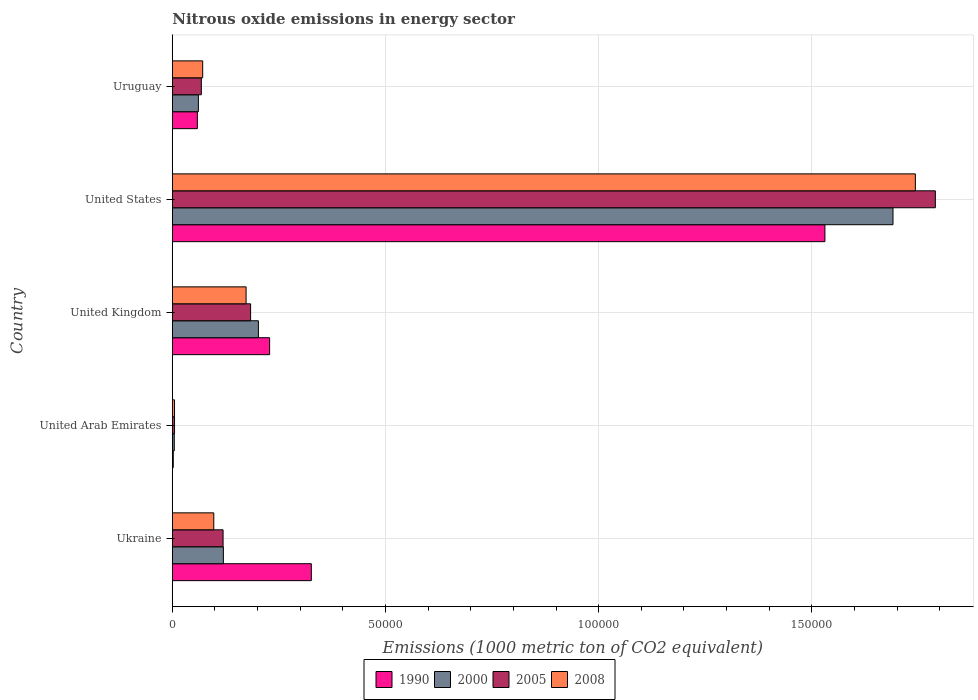How many bars are there on the 2nd tick from the top?
Your answer should be compact. 4. What is the label of the 5th group of bars from the top?
Provide a short and direct response. Ukraine. What is the amount of nitrous oxide emitted in 1990 in United States?
Provide a succinct answer. 1.53e+05. Across all countries, what is the maximum amount of nitrous oxide emitted in 2005?
Provide a short and direct response. 1.79e+05. Across all countries, what is the minimum amount of nitrous oxide emitted in 2000?
Keep it short and to the point. 453.6. In which country was the amount of nitrous oxide emitted in 2000 minimum?
Your response must be concise. United Arab Emirates. What is the total amount of nitrous oxide emitted in 1990 in the graph?
Your response must be concise. 2.15e+05. What is the difference between the amount of nitrous oxide emitted in 1990 in Ukraine and that in United Kingdom?
Ensure brevity in your answer.  9785.4. What is the difference between the amount of nitrous oxide emitted in 1990 in Ukraine and the amount of nitrous oxide emitted in 2000 in Uruguay?
Your response must be concise. 2.65e+04. What is the average amount of nitrous oxide emitted in 1990 per country?
Your answer should be very brief. 4.29e+04. What is the difference between the amount of nitrous oxide emitted in 2008 and amount of nitrous oxide emitted in 1990 in United States?
Ensure brevity in your answer.  2.12e+04. What is the ratio of the amount of nitrous oxide emitted in 1990 in Ukraine to that in United Kingdom?
Keep it short and to the point. 1.43. What is the difference between the highest and the second highest amount of nitrous oxide emitted in 2005?
Provide a succinct answer. 1.61e+05. What is the difference between the highest and the lowest amount of nitrous oxide emitted in 2000?
Provide a short and direct response. 1.69e+05. In how many countries, is the amount of nitrous oxide emitted in 2000 greater than the average amount of nitrous oxide emitted in 2000 taken over all countries?
Provide a succinct answer. 1. Is the sum of the amount of nitrous oxide emitted in 2000 in United Arab Emirates and Uruguay greater than the maximum amount of nitrous oxide emitted in 2008 across all countries?
Give a very brief answer. No. Is it the case that in every country, the sum of the amount of nitrous oxide emitted in 2000 and amount of nitrous oxide emitted in 2005 is greater than the sum of amount of nitrous oxide emitted in 2008 and amount of nitrous oxide emitted in 1990?
Provide a short and direct response. No. What does the 3rd bar from the top in United States represents?
Make the answer very short. 2000. Is it the case that in every country, the sum of the amount of nitrous oxide emitted in 1990 and amount of nitrous oxide emitted in 2000 is greater than the amount of nitrous oxide emitted in 2005?
Your response must be concise. Yes. Are all the bars in the graph horizontal?
Your answer should be very brief. Yes. Are the values on the major ticks of X-axis written in scientific E-notation?
Provide a short and direct response. No. Does the graph contain any zero values?
Ensure brevity in your answer.  No. Where does the legend appear in the graph?
Provide a short and direct response. Bottom center. How many legend labels are there?
Keep it short and to the point. 4. How are the legend labels stacked?
Give a very brief answer. Horizontal. What is the title of the graph?
Provide a succinct answer. Nitrous oxide emissions in energy sector. What is the label or title of the X-axis?
Give a very brief answer. Emissions (1000 metric ton of CO2 equivalent). What is the label or title of the Y-axis?
Make the answer very short. Country. What is the Emissions (1000 metric ton of CO2 equivalent) of 1990 in Ukraine?
Your response must be concise. 3.26e+04. What is the Emissions (1000 metric ton of CO2 equivalent) of 2000 in Ukraine?
Offer a terse response. 1.20e+04. What is the Emissions (1000 metric ton of CO2 equivalent) of 2005 in Ukraine?
Make the answer very short. 1.19e+04. What is the Emissions (1000 metric ton of CO2 equivalent) of 2008 in Ukraine?
Your answer should be compact. 9719.1. What is the Emissions (1000 metric ton of CO2 equivalent) of 1990 in United Arab Emirates?
Offer a terse response. 214.5. What is the Emissions (1000 metric ton of CO2 equivalent) of 2000 in United Arab Emirates?
Provide a succinct answer. 453.6. What is the Emissions (1000 metric ton of CO2 equivalent) of 2005 in United Arab Emirates?
Your answer should be very brief. 510.2. What is the Emissions (1000 metric ton of CO2 equivalent) in 2008 in United Arab Emirates?
Your response must be concise. 507.7. What is the Emissions (1000 metric ton of CO2 equivalent) of 1990 in United Kingdom?
Provide a succinct answer. 2.28e+04. What is the Emissions (1000 metric ton of CO2 equivalent) in 2000 in United Kingdom?
Give a very brief answer. 2.02e+04. What is the Emissions (1000 metric ton of CO2 equivalent) in 2005 in United Kingdom?
Your response must be concise. 1.84e+04. What is the Emissions (1000 metric ton of CO2 equivalent) of 2008 in United Kingdom?
Offer a very short reply. 1.73e+04. What is the Emissions (1000 metric ton of CO2 equivalent) in 1990 in United States?
Your answer should be compact. 1.53e+05. What is the Emissions (1000 metric ton of CO2 equivalent) of 2000 in United States?
Make the answer very short. 1.69e+05. What is the Emissions (1000 metric ton of CO2 equivalent) of 2005 in United States?
Give a very brief answer. 1.79e+05. What is the Emissions (1000 metric ton of CO2 equivalent) in 2008 in United States?
Your answer should be very brief. 1.74e+05. What is the Emissions (1000 metric ton of CO2 equivalent) of 1990 in Uruguay?
Provide a short and direct response. 5867.6. What is the Emissions (1000 metric ton of CO2 equivalent) in 2000 in Uruguay?
Offer a terse response. 6109. What is the Emissions (1000 metric ton of CO2 equivalent) in 2005 in Uruguay?
Your answer should be very brief. 6798.2. What is the Emissions (1000 metric ton of CO2 equivalent) of 2008 in Uruguay?
Provide a succinct answer. 7116. Across all countries, what is the maximum Emissions (1000 metric ton of CO2 equivalent) of 1990?
Offer a terse response. 1.53e+05. Across all countries, what is the maximum Emissions (1000 metric ton of CO2 equivalent) of 2000?
Offer a terse response. 1.69e+05. Across all countries, what is the maximum Emissions (1000 metric ton of CO2 equivalent) in 2005?
Offer a terse response. 1.79e+05. Across all countries, what is the maximum Emissions (1000 metric ton of CO2 equivalent) in 2008?
Provide a succinct answer. 1.74e+05. Across all countries, what is the minimum Emissions (1000 metric ton of CO2 equivalent) of 1990?
Make the answer very short. 214.5. Across all countries, what is the minimum Emissions (1000 metric ton of CO2 equivalent) in 2000?
Keep it short and to the point. 453.6. Across all countries, what is the minimum Emissions (1000 metric ton of CO2 equivalent) in 2005?
Give a very brief answer. 510.2. Across all countries, what is the minimum Emissions (1000 metric ton of CO2 equivalent) of 2008?
Provide a succinct answer. 507.7. What is the total Emissions (1000 metric ton of CO2 equivalent) in 1990 in the graph?
Give a very brief answer. 2.15e+05. What is the total Emissions (1000 metric ton of CO2 equivalent) in 2000 in the graph?
Make the answer very short. 2.08e+05. What is the total Emissions (1000 metric ton of CO2 equivalent) in 2005 in the graph?
Give a very brief answer. 2.17e+05. What is the total Emissions (1000 metric ton of CO2 equivalent) of 2008 in the graph?
Your answer should be compact. 2.09e+05. What is the difference between the Emissions (1000 metric ton of CO2 equivalent) in 1990 in Ukraine and that in United Arab Emirates?
Your answer should be compact. 3.24e+04. What is the difference between the Emissions (1000 metric ton of CO2 equivalent) in 2000 in Ukraine and that in United Arab Emirates?
Your answer should be very brief. 1.15e+04. What is the difference between the Emissions (1000 metric ton of CO2 equivalent) of 2005 in Ukraine and that in United Arab Emirates?
Your answer should be very brief. 1.14e+04. What is the difference between the Emissions (1000 metric ton of CO2 equivalent) in 2008 in Ukraine and that in United Arab Emirates?
Your answer should be compact. 9211.4. What is the difference between the Emissions (1000 metric ton of CO2 equivalent) in 1990 in Ukraine and that in United Kingdom?
Offer a very short reply. 9785.4. What is the difference between the Emissions (1000 metric ton of CO2 equivalent) in 2000 in Ukraine and that in United Kingdom?
Offer a terse response. -8217.1. What is the difference between the Emissions (1000 metric ton of CO2 equivalent) in 2005 in Ukraine and that in United Kingdom?
Give a very brief answer. -6455.5. What is the difference between the Emissions (1000 metric ton of CO2 equivalent) of 2008 in Ukraine and that in United Kingdom?
Keep it short and to the point. -7578.1. What is the difference between the Emissions (1000 metric ton of CO2 equivalent) of 1990 in Ukraine and that in United States?
Give a very brief answer. -1.20e+05. What is the difference between the Emissions (1000 metric ton of CO2 equivalent) of 2000 in Ukraine and that in United States?
Your answer should be compact. -1.57e+05. What is the difference between the Emissions (1000 metric ton of CO2 equivalent) in 2005 in Ukraine and that in United States?
Your response must be concise. -1.67e+05. What is the difference between the Emissions (1000 metric ton of CO2 equivalent) of 2008 in Ukraine and that in United States?
Ensure brevity in your answer.  -1.65e+05. What is the difference between the Emissions (1000 metric ton of CO2 equivalent) of 1990 in Ukraine and that in Uruguay?
Make the answer very short. 2.67e+04. What is the difference between the Emissions (1000 metric ton of CO2 equivalent) of 2000 in Ukraine and that in Uruguay?
Keep it short and to the point. 5858.9. What is the difference between the Emissions (1000 metric ton of CO2 equivalent) in 2005 in Ukraine and that in Uruguay?
Offer a terse response. 5099.3. What is the difference between the Emissions (1000 metric ton of CO2 equivalent) of 2008 in Ukraine and that in Uruguay?
Make the answer very short. 2603.1. What is the difference between the Emissions (1000 metric ton of CO2 equivalent) in 1990 in United Arab Emirates and that in United Kingdom?
Offer a terse response. -2.26e+04. What is the difference between the Emissions (1000 metric ton of CO2 equivalent) in 2000 in United Arab Emirates and that in United Kingdom?
Offer a very short reply. -1.97e+04. What is the difference between the Emissions (1000 metric ton of CO2 equivalent) of 2005 in United Arab Emirates and that in United Kingdom?
Make the answer very short. -1.78e+04. What is the difference between the Emissions (1000 metric ton of CO2 equivalent) in 2008 in United Arab Emirates and that in United Kingdom?
Your answer should be compact. -1.68e+04. What is the difference between the Emissions (1000 metric ton of CO2 equivalent) of 1990 in United Arab Emirates and that in United States?
Your answer should be compact. -1.53e+05. What is the difference between the Emissions (1000 metric ton of CO2 equivalent) in 2000 in United Arab Emirates and that in United States?
Offer a very short reply. -1.69e+05. What is the difference between the Emissions (1000 metric ton of CO2 equivalent) of 2005 in United Arab Emirates and that in United States?
Offer a terse response. -1.78e+05. What is the difference between the Emissions (1000 metric ton of CO2 equivalent) in 2008 in United Arab Emirates and that in United States?
Your answer should be very brief. -1.74e+05. What is the difference between the Emissions (1000 metric ton of CO2 equivalent) in 1990 in United Arab Emirates and that in Uruguay?
Your response must be concise. -5653.1. What is the difference between the Emissions (1000 metric ton of CO2 equivalent) in 2000 in United Arab Emirates and that in Uruguay?
Ensure brevity in your answer.  -5655.4. What is the difference between the Emissions (1000 metric ton of CO2 equivalent) in 2005 in United Arab Emirates and that in Uruguay?
Ensure brevity in your answer.  -6288. What is the difference between the Emissions (1000 metric ton of CO2 equivalent) in 2008 in United Arab Emirates and that in Uruguay?
Give a very brief answer. -6608.3. What is the difference between the Emissions (1000 metric ton of CO2 equivalent) of 1990 in United Kingdom and that in United States?
Provide a short and direct response. -1.30e+05. What is the difference between the Emissions (1000 metric ton of CO2 equivalent) of 2000 in United Kingdom and that in United States?
Keep it short and to the point. -1.49e+05. What is the difference between the Emissions (1000 metric ton of CO2 equivalent) of 2005 in United Kingdom and that in United States?
Offer a very short reply. -1.61e+05. What is the difference between the Emissions (1000 metric ton of CO2 equivalent) in 2008 in United Kingdom and that in United States?
Your response must be concise. -1.57e+05. What is the difference between the Emissions (1000 metric ton of CO2 equivalent) of 1990 in United Kingdom and that in Uruguay?
Give a very brief answer. 1.69e+04. What is the difference between the Emissions (1000 metric ton of CO2 equivalent) in 2000 in United Kingdom and that in Uruguay?
Give a very brief answer. 1.41e+04. What is the difference between the Emissions (1000 metric ton of CO2 equivalent) in 2005 in United Kingdom and that in Uruguay?
Offer a very short reply. 1.16e+04. What is the difference between the Emissions (1000 metric ton of CO2 equivalent) of 2008 in United Kingdom and that in Uruguay?
Provide a short and direct response. 1.02e+04. What is the difference between the Emissions (1000 metric ton of CO2 equivalent) in 1990 in United States and that in Uruguay?
Give a very brief answer. 1.47e+05. What is the difference between the Emissions (1000 metric ton of CO2 equivalent) in 2000 in United States and that in Uruguay?
Provide a succinct answer. 1.63e+05. What is the difference between the Emissions (1000 metric ton of CO2 equivalent) in 2005 in United States and that in Uruguay?
Give a very brief answer. 1.72e+05. What is the difference between the Emissions (1000 metric ton of CO2 equivalent) of 2008 in United States and that in Uruguay?
Offer a very short reply. 1.67e+05. What is the difference between the Emissions (1000 metric ton of CO2 equivalent) in 1990 in Ukraine and the Emissions (1000 metric ton of CO2 equivalent) in 2000 in United Arab Emirates?
Your answer should be very brief. 3.21e+04. What is the difference between the Emissions (1000 metric ton of CO2 equivalent) in 1990 in Ukraine and the Emissions (1000 metric ton of CO2 equivalent) in 2005 in United Arab Emirates?
Your response must be concise. 3.21e+04. What is the difference between the Emissions (1000 metric ton of CO2 equivalent) in 1990 in Ukraine and the Emissions (1000 metric ton of CO2 equivalent) in 2008 in United Arab Emirates?
Provide a succinct answer. 3.21e+04. What is the difference between the Emissions (1000 metric ton of CO2 equivalent) of 2000 in Ukraine and the Emissions (1000 metric ton of CO2 equivalent) of 2005 in United Arab Emirates?
Provide a succinct answer. 1.15e+04. What is the difference between the Emissions (1000 metric ton of CO2 equivalent) in 2000 in Ukraine and the Emissions (1000 metric ton of CO2 equivalent) in 2008 in United Arab Emirates?
Your response must be concise. 1.15e+04. What is the difference between the Emissions (1000 metric ton of CO2 equivalent) of 2005 in Ukraine and the Emissions (1000 metric ton of CO2 equivalent) of 2008 in United Arab Emirates?
Offer a terse response. 1.14e+04. What is the difference between the Emissions (1000 metric ton of CO2 equivalent) in 1990 in Ukraine and the Emissions (1000 metric ton of CO2 equivalent) in 2000 in United Kingdom?
Give a very brief answer. 1.24e+04. What is the difference between the Emissions (1000 metric ton of CO2 equivalent) of 1990 in Ukraine and the Emissions (1000 metric ton of CO2 equivalent) of 2005 in United Kingdom?
Keep it short and to the point. 1.42e+04. What is the difference between the Emissions (1000 metric ton of CO2 equivalent) in 1990 in Ukraine and the Emissions (1000 metric ton of CO2 equivalent) in 2008 in United Kingdom?
Provide a succinct answer. 1.53e+04. What is the difference between the Emissions (1000 metric ton of CO2 equivalent) in 2000 in Ukraine and the Emissions (1000 metric ton of CO2 equivalent) in 2005 in United Kingdom?
Make the answer very short. -6385.1. What is the difference between the Emissions (1000 metric ton of CO2 equivalent) of 2000 in Ukraine and the Emissions (1000 metric ton of CO2 equivalent) of 2008 in United Kingdom?
Make the answer very short. -5329.3. What is the difference between the Emissions (1000 metric ton of CO2 equivalent) in 2005 in Ukraine and the Emissions (1000 metric ton of CO2 equivalent) in 2008 in United Kingdom?
Provide a short and direct response. -5399.7. What is the difference between the Emissions (1000 metric ton of CO2 equivalent) of 1990 in Ukraine and the Emissions (1000 metric ton of CO2 equivalent) of 2000 in United States?
Your answer should be compact. -1.36e+05. What is the difference between the Emissions (1000 metric ton of CO2 equivalent) in 1990 in Ukraine and the Emissions (1000 metric ton of CO2 equivalent) in 2005 in United States?
Offer a very short reply. -1.46e+05. What is the difference between the Emissions (1000 metric ton of CO2 equivalent) in 1990 in Ukraine and the Emissions (1000 metric ton of CO2 equivalent) in 2008 in United States?
Keep it short and to the point. -1.42e+05. What is the difference between the Emissions (1000 metric ton of CO2 equivalent) in 2000 in Ukraine and the Emissions (1000 metric ton of CO2 equivalent) in 2005 in United States?
Your answer should be very brief. -1.67e+05. What is the difference between the Emissions (1000 metric ton of CO2 equivalent) in 2000 in Ukraine and the Emissions (1000 metric ton of CO2 equivalent) in 2008 in United States?
Your response must be concise. -1.62e+05. What is the difference between the Emissions (1000 metric ton of CO2 equivalent) of 2005 in Ukraine and the Emissions (1000 metric ton of CO2 equivalent) of 2008 in United States?
Your answer should be compact. -1.62e+05. What is the difference between the Emissions (1000 metric ton of CO2 equivalent) of 1990 in Ukraine and the Emissions (1000 metric ton of CO2 equivalent) of 2000 in Uruguay?
Ensure brevity in your answer.  2.65e+04. What is the difference between the Emissions (1000 metric ton of CO2 equivalent) in 1990 in Ukraine and the Emissions (1000 metric ton of CO2 equivalent) in 2005 in Uruguay?
Keep it short and to the point. 2.58e+04. What is the difference between the Emissions (1000 metric ton of CO2 equivalent) in 1990 in Ukraine and the Emissions (1000 metric ton of CO2 equivalent) in 2008 in Uruguay?
Offer a terse response. 2.55e+04. What is the difference between the Emissions (1000 metric ton of CO2 equivalent) in 2000 in Ukraine and the Emissions (1000 metric ton of CO2 equivalent) in 2005 in Uruguay?
Make the answer very short. 5169.7. What is the difference between the Emissions (1000 metric ton of CO2 equivalent) in 2000 in Ukraine and the Emissions (1000 metric ton of CO2 equivalent) in 2008 in Uruguay?
Your response must be concise. 4851.9. What is the difference between the Emissions (1000 metric ton of CO2 equivalent) of 2005 in Ukraine and the Emissions (1000 metric ton of CO2 equivalent) of 2008 in Uruguay?
Provide a short and direct response. 4781.5. What is the difference between the Emissions (1000 metric ton of CO2 equivalent) in 1990 in United Arab Emirates and the Emissions (1000 metric ton of CO2 equivalent) in 2000 in United Kingdom?
Provide a succinct answer. -2.00e+04. What is the difference between the Emissions (1000 metric ton of CO2 equivalent) in 1990 in United Arab Emirates and the Emissions (1000 metric ton of CO2 equivalent) in 2005 in United Kingdom?
Make the answer very short. -1.81e+04. What is the difference between the Emissions (1000 metric ton of CO2 equivalent) of 1990 in United Arab Emirates and the Emissions (1000 metric ton of CO2 equivalent) of 2008 in United Kingdom?
Provide a succinct answer. -1.71e+04. What is the difference between the Emissions (1000 metric ton of CO2 equivalent) of 2000 in United Arab Emirates and the Emissions (1000 metric ton of CO2 equivalent) of 2005 in United Kingdom?
Ensure brevity in your answer.  -1.79e+04. What is the difference between the Emissions (1000 metric ton of CO2 equivalent) of 2000 in United Arab Emirates and the Emissions (1000 metric ton of CO2 equivalent) of 2008 in United Kingdom?
Offer a very short reply. -1.68e+04. What is the difference between the Emissions (1000 metric ton of CO2 equivalent) in 2005 in United Arab Emirates and the Emissions (1000 metric ton of CO2 equivalent) in 2008 in United Kingdom?
Offer a terse response. -1.68e+04. What is the difference between the Emissions (1000 metric ton of CO2 equivalent) in 1990 in United Arab Emirates and the Emissions (1000 metric ton of CO2 equivalent) in 2000 in United States?
Provide a succinct answer. -1.69e+05. What is the difference between the Emissions (1000 metric ton of CO2 equivalent) of 1990 in United Arab Emirates and the Emissions (1000 metric ton of CO2 equivalent) of 2005 in United States?
Ensure brevity in your answer.  -1.79e+05. What is the difference between the Emissions (1000 metric ton of CO2 equivalent) in 1990 in United Arab Emirates and the Emissions (1000 metric ton of CO2 equivalent) in 2008 in United States?
Offer a terse response. -1.74e+05. What is the difference between the Emissions (1000 metric ton of CO2 equivalent) in 2000 in United Arab Emirates and the Emissions (1000 metric ton of CO2 equivalent) in 2005 in United States?
Keep it short and to the point. -1.79e+05. What is the difference between the Emissions (1000 metric ton of CO2 equivalent) of 2000 in United Arab Emirates and the Emissions (1000 metric ton of CO2 equivalent) of 2008 in United States?
Your answer should be very brief. -1.74e+05. What is the difference between the Emissions (1000 metric ton of CO2 equivalent) of 2005 in United Arab Emirates and the Emissions (1000 metric ton of CO2 equivalent) of 2008 in United States?
Provide a succinct answer. -1.74e+05. What is the difference between the Emissions (1000 metric ton of CO2 equivalent) in 1990 in United Arab Emirates and the Emissions (1000 metric ton of CO2 equivalent) in 2000 in Uruguay?
Provide a short and direct response. -5894.5. What is the difference between the Emissions (1000 metric ton of CO2 equivalent) of 1990 in United Arab Emirates and the Emissions (1000 metric ton of CO2 equivalent) of 2005 in Uruguay?
Offer a terse response. -6583.7. What is the difference between the Emissions (1000 metric ton of CO2 equivalent) of 1990 in United Arab Emirates and the Emissions (1000 metric ton of CO2 equivalent) of 2008 in Uruguay?
Make the answer very short. -6901.5. What is the difference between the Emissions (1000 metric ton of CO2 equivalent) in 2000 in United Arab Emirates and the Emissions (1000 metric ton of CO2 equivalent) in 2005 in Uruguay?
Give a very brief answer. -6344.6. What is the difference between the Emissions (1000 metric ton of CO2 equivalent) in 2000 in United Arab Emirates and the Emissions (1000 metric ton of CO2 equivalent) in 2008 in Uruguay?
Offer a very short reply. -6662.4. What is the difference between the Emissions (1000 metric ton of CO2 equivalent) in 2005 in United Arab Emirates and the Emissions (1000 metric ton of CO2 equivalent) in 2008 in Uruguay?
Your response must be concise. -6605.8. What is the difference between the Emissions (1000 metric ton of CO2 equivalent) of 1990 in United Kingdom and the Emissions (1000 metric ton of CO2 equivalent) of 2000 in United States?
Your answer should be compact. -1.46e+05. What is the difference between the Emissions (1000 metric ton of CO2 equivalent) in 1990 in United Kingdom and the Emissions (1000 metric ton of CO2 equivalent) in 2005 in United States?
Your answer should be very brief. -1.56e+05. What is the difference between the Emissions (1000 metric ton of CO2 equivalent) of 1990 in United Kingdom and the Emissions (1000 metric ton of CO2 equivalent) of 2008 in United States?
Provide a succinct answer. -1.51e+05. What is the difference between the Emissions (1000 metric ton of CO2 equivalent) of 2000 in United Kingdom and the Emissions (1000 metric ton of CO2 equivalent) of 2005 in United States?
Your response must be concise. -1.59e+05. What is the difference between the Emissions (1000 metric ton of CO2 equivalent) in 2000 in United Kingdom and the Emissions (1000 metric ton of CO2 equivalent) in 2008 in United States?
Your answer should be compact. -1.54e+05. What is the difference between the Emissions (1000 metric ton of CO2 equivalent) in 2005 in United Kingdom and the Emissions (1000 metric ton of CO2 equivalent) in 2008 in United States?
Your answer should be compact. -1.56e+05. What is the difference between the Emissions (1000 metric ton of CO2 equivalent) of 1990 in United Kingdom and the Emissions (1000 metric ton of CO2 equivalent) of 2000 in Uruguay?
Provide a short and direct response. 1.67e+04. What is the difference between the Emissions (1000 metric ton of CO2 equivalent) of 1990 in United Kingdom and the Emissions (1000 metric ton of CO2 equivalent) of 2005 in Uruguay?
Make the answer very short. 1.60e+04. What is the difference between the Emissions (1000 metric ton of CO2 equivalent) of 1990 in United Kingdom and the Emissions (1000 metric ton of CO2 equivalent) of 2008 in Uruguay?
Your answer should be very brief. 1.57e+04. What is the difference between the Emissions (1000 metric ton of CO2 equivalent) of 2000 in United Kingdom and the Emissions (1000 metric ton of CO2 equivalent) of 2005 in Uruguay?
Make the answer very short. 1.34e+04. What is the difference between the Emissions (1000 metric ton of CO2 equivalent) in 2000 in United Kingdom and the Emissions (1000 metric ton of CO2 equivalent) in 2008 in Uruguay?
Provide a short and direct response. 1.31e+04. What is the difference between the Emissions (1000 metric ton of CO2 equivalent) in 2005 in United Kingdom and the Emissions (1000 metric ton of CO2 equivalent) in 2008 in Uruguay?
Provide a succinct answer. 1.12e+04. What is the difference between the Emissions (1000 metric ton of CO2 equivalent) in 1990 in United States and the Emissions (1000 metric ton of CO2 equivalent) in 2000 in Uruguay?
Give a very brief answer. 1.47e+05. What is the difference between the Emissions (1000 metric ton of CO2 equivalent) in 1990 in United States and the Emissions (1000 metric ton of CO2 equivalent) in 2005 in Uruguay?
Ensure brevity in your answer.  1.46e+05. What is the difference between the Emissions (1000 metric ton of CO2 equivalent) of 1990 in United States and the Emissions (1000 metric ton of CO2 equivalent) of 2008 in Uruguay?
Offer a very short reply. 1.46e+05. What is the difference between the Emissions (1000 metric ton of CO2 equivalent) of 2000 in United States and the Emissions (1000 metric ton of CO2 equivalent) of 2005 in Uruguay?
Make the answer very short. 1.62e+05. What is the difference between the Emissions (1000 metric ton of CO2 equivalent) in 2000 in United States and the Emissions (1000 metric ton of CO2 equivalent) in 2008 in Uruguay?
Ensure brevity in your answer.  1.62e+05. What is the difference between the Emissions (1000 metric ton of CO2 equivalent) in 2005 in United States and the Emissions (1000 metric ton of CO2 equivalent) in 2008 in Uruguay?
Provide a succinct answer. 1.72e+05. What is the average Emissions (1000 metric ton of CO2 equivalent) in 1990 per country?
Make the answer very short. 4.29e+04. What is the average Emissions (1000 metric ton of CO2 equivalent) of 2000 per country?
Offer a very short reply. 4.16e+04. What is the average Emissions (1000 metric ton of CO2 equivalent) in 2005 per country?
Your answer should be compact. 4.33e+04. What is the average Emissions (1000 metric ton of CO2 equivalent) in 2008 per country?
Ensure brevity in your answer.  4.18e+04. What is the difference between the Emissions (1000 metric ton of CO2 equivalent) in 1990 and Emissions (1000 metric ton of CO2 equivalent) in 2000 in Ukraine?
Ensure brevity in your answer.  2.06e+04. What is the difference between the Emissions (1000 metric ton of CO2 equivalent) of 1990 and Emissions (1000 metric ton of CO2 equivalent) of 2005 in Ukraine?
Your response must be concise. 2.07e+04. What is the difference between the Emissions (1000 metric ton of CO2 equivalent) in 1990 and Emissions (1000 metric ton of CO2 equivalent) in 2008 in Ukraine?
Provide a short and direct response. 2.29e+04. What is the difference between the Emissions (1000 metric ton of CO2 equivalent) in 2000 and Emissions (1000 metric ton of CO2 equivalent) in 2005 in Ukraine?
Your response must be concise. 70.4. What is the difference between the Emissions (1000 metric ton of CO2 equivalent) of 2000 and Emissions (1000 metric ton of CO2 equivalent) of 2008 in Ukraine?
Your answer should be compact. 2248.8. What is the difference between the Emissions (1000 metric ton of CO2 equivalent) of 2005 and Emissions (1000 metric ton of CO2 equivalent) of 2008 in Ukraine?
Offer a terse response. 2178.4. What is the difference between the Emissions (1000 metric ton of CO2 equivalent) in 1990 and Emissions (1000 metric ton of CO2 equivalent) in 2000 in United Arab Emirates?
Offer a very short reply. -239.1. What is the difference between the Emissions (1000 metric ton of CO2 equivalent) in 1990 and Emissions (1000 metric ton of CO2 equivalent) in 2005 in United Arab Emirates?
Your answer should be compact. -295.7. What is the difference between the Emissions (1000 metric ton of CO2 equivalent) of 1990 and Emissions (1000 metric ton of CO2 equivalent) of 2008 in United Arab Emirates?
Your response must be concise. -293.2. What is the difference between the Emissions (1000 metric ton of CO2 equivalent) of 2000 and Emissions (1000 metric ton of CO2 equivalent) of 2005 in United Arab Emirates?
Make the answer very short. -56.6. What is the difference between the Emissions (1000 metric ton of CO2 equivalent) of 2000 and Emissions (1000 metric ton of CO2 equivalent) of 2008 in United Arab Emirates?
Your answer should be very brief. -54.1. What is the difference between the Emissions (1000 metric ton of CO2 equivalent) of 2005 and Emissions (1000 metric ton of CO2 equivalent) of 2008 in United Arab Emirates?
Give a very brief answer. 2.5. What is the difference between the Emissions (1000 metric ton of CO2 equivalent) of 1990 and Emissions (1000 metric ton of CO2 equivalent) of 2000 in United Kingdom?
Your answer should be compact. 2628.9. What is the difference between the Emissions (1000 metric ton of CO2 equivalent) in 1990 and Emissions (1000 metric ton of CO2 equivalent) in 2005 in United Kingdom?
Offer a terse response. 4460.9. What is the difference between the Emissions (1000 metric ton of CO2 equivalent) in 1990 and Emissions (1000 metric ton of CO2 equivalent) in 2008 in United Kingdom?
Your answer should be compact. 5516.7. What is the difference between the Emissions (1000 metric ton of CO2 equivalent) of 2000 and Emissions (1000 metric ton of CO2 equivalent) of 2005 in United Kingdom?
Your response must be concise. 1832. What is the difference between the Emissions (1000 metric ton of CO2 equivalent) of 2000 and Emissions (1000 metric ton of CO2 equivalent) of 2008 in United Kingdom?
Your response must be concise. 2887.8. What is the difference between the Emissions (1000 metric ton of CO2 equivalent) of 2005 and Emissions (1000 metric ton of CO2 equivalent) of 2008 in United Kingdom?
Your response must be concise. 1055.8. What is the difference between the Emissions (1000 metric ton of CO2 equivalent) in 1990 and Emissions (1000 metric ton of CO2 equivalent) in 2000 in United States?
Offer a terse response. -1.60e+04. What is the difference between the Emissions (1000 metric ton of CO2 equivalent) of 1990 and Emissions (1000 metric ton of CO2 equivalent) of 2005 in United States?
Your answer should be compact. -2.59e+04. What is the difference between the Emissions (1000 metric ton of CO2 equivalent) in 1990 and Emissions (1000 metric ton of CO2 equivalent) in 2008 in United States?
Provide a succinct answer. -2.12e+04. What is the difference between the Emissions (1000 metric ton of CO2 equivalent) of 2000 and Emissions (1000 metric ton of CO2 equivalent) of 2005 in United States?
Your answer should be very brief. -9931.2. What is the difference between the Emissions (1000 metric ton of CO2 equivalent) of 2000 and Emissions (1000 metric ton of CO2 equivalent) of 2008 in United States?
Keep it short and to the point. -5242.4. What is the difference between the Emissions (1000 metric ton of CO2 equivalent) in 2005 and Emissions (1000 metric ton of CO2 equivalent) in 2008 in United States?
Give a very brief answer. 4688.8. What is the difference between the Emissions (1000 metric ton of CO2 equivalent) in 1990 and Emissions (1000 metric ton of CO2 equivalent) in 2000 in Uruguay?
Offer a terse response. -241.4. What is the difference between the Emissions (1000 metric ton of CO2 equivalent) of 1990 and Emissions (1000 metric ton of CO2 equivalent) of 2005 in Uruguay?
Offer a very short reply. -930.6. What is the difference between the Emissions (1000 metric ton of CO2 equivalent) in 1990 and Emissions (1000 metric ton of CO2 equivalent) in 2008 in Uruguay?
Provide a short and direct response. -1248.4. What is the difference between the Emissions (1000 metric ton of CO2 equivalent) of 2000 and Emissions (1000 metric ton of CO2 equivalent) of 2005 in Uruguay?
Ensure brevity in your answer.  -689.2. What is the difference between the Emissions (1000 metric ton of CO2 equivalent) in 2000 and Emissions (1000 metric ton of CO2 equivalent) in 2008 in Uruguay?
Your response must be concise. -1007. What is the difference between the Emissions (1000 metric ton of CO2 equivalent) of 2005 and Emissions (1000 metric ton of CO2 equivalent) of 2008 in Uruguay?
Your response must be concise. -317.8. What is the ratio of the Emissions (1000 metric ton of CO2 equivalent) in 1990 in Ukraine to that in United Arab Emirates?
Offer a terse response. 151.98. What is the ratio of the Emissions (1000 metric ton of CO2 equivalent) of 2000 in Ukraine to that in United Arab Emirates?
Ensure brevity in your answer.  26.38. What is the ratio of the Emissions (1000 metric ton of CO2 equivalent) in 2005 in Ukraine to that in United Arab Emirates?
Keep it short and to the point. 23.32. What is the ratio of the Emissions (1000 metric ton of CO2 equivalent) in 2008 in Ukraine to that in United Arab Emirates?
Give a very brief answer. 19.14. What is the ratio of the Emissions (1000 metric ton of CO2 equivalent) in 1990 in Ukraine to that in United Kingdom?
Ensure brevity in your answer.  1.43. What is the ratio of the Emissions (1000 metric ton of CO2 equivalent) of 2000 in Ukraine to that in United Kingdom?
Your response must be concise. 0.59. What is the ratio of the Emissions (1000 metric ton of CO2 equivalent) of 2005 in Ukraine to that in United Kingdom?
Provide a short and direct response. 0.65. What is the ratio of the Emissions (1000 metric ton of CO2 equivalent) in 2008 in Ukraine to that in United Kingdom?
Make the answer very short. 0.56. What is the ratio of the Emissions (1000 metric ton of CO2 equivalent) in 1990 in Ukraine to that in United States?
Offer a very short reply. 0.21. What is the ratio of the Emissions (1000 metric ton of CO2 equivalent) of 2000 in Ukraine to that in United States?
Give a very brief answer. 0.07. What is the ratio of the Emissions (1000 metric ton of CO2 equivalent) in 2005 in Ukraine to that in United States?
Ensure brevity in your answer.  0.07. What is the ratio of the Emissions (1000 metric ton of CO2 equivalent) of 2008 in Ukraine to that in United States?
Your answer should be compact. 0.06. What is the ratio of the Emissions (1000 metric ton of CO2 equivalent) in 1990 in Ukraine to that in Uruguay?
Offer a terse response. 5.56. What is the ratio of the Emissions (1000 metric ton of CO2 equivalent) in 2000 in Ukraine to that in Uruguay?
Provide a short and direct response. 1.96. What is the ratio of the Emissions (1000 metric ton of CO2 equivalent) in 2005 in Ukraine to that in Uruguay?
Offer a terse response. 1.75. What is the ratio of the Emissions (1000 metric ton of CO2 equivalent) of 2008 in Ukraine to that in Uruguay?
Your answer should be very brief. 1.37. What is the ratio of the Emissions (1000 metric ton of CO2 equivalent) of 1990 in United Arab Emirates to that in United Kingdom?
Ensure brevity in your answer.  0.01. What is the ratio of the Emissions (1000 metric ton of CO2 equivalent) in 2000 in United Arab Emirates to that in United Kingdom?
Keep it short and to the point. 0.02. What is the ratio of the Emissions (1000 metric ton of CO2 equivalent) in 2005 in United Arab Emirates to that in United Kingdom?
Offer a terse response. 0.03. What is the ratio of the Emissions (1000 metric ton of CO2 equivalent) of 2008 in United Arab Emirates to that in United Kingdom?
Ensure brevity in your answer.  0.03. What is the ratio of the Emissions (1000 metric ton of CO2 equivalent) of 1990 in United Arab Emirates to that in United States?
Ensure brevity in your answer.  0. What is the ratio of the Emissions (1000 metric ton of CO2 equivalent) in 2000 in United Arab Emirates to that in United States?
Provide a short and direct response. 0. What is the ratio of the Emissions (1000 metric ton of CO2 equivalent) in 2005 in United Arab Emirates to that in United States?
Provide a succinct answer. 0. What is the ratio of the Emissions (1000 metric ton of CO2 equivalent) in 2008 in United Arab Emirates to that in United States?
Your answer should be very brief. 0. What is the ratio of the Emissions (1000 metric ton of CO2 equivalent) of 1990 in United Arab Emirates to that in Uruguay?
Your answer should be very brief. 0.04. What is the ratio of the Emissions (1000 metric ton of CO2 equivalent) in 2000 in United Arab Emirates to that in Uruguay?
Keep it short and to the point. 0.07. What is the ratio of the Emissions (1000 metric ton of CO2 equivalent) in 2005 in United Arab Emirates to that in Uruguay?
Keep it short and to the point. 0.07. What is the ratio of the Emissions (1000 metric ton of CO2 equivalent) of 2008 in United Arab Emirates to that in Uruguay?
Keep it short and to the point. 0.07. What is the ratio of the Emissions (1000 metric ton of CO2 equivalent) of 1990 in United Kingdom to that in United States?
Make the answer very short. 0.15. What is the ratio of the Emissions (1000 metric ton of CO2 equivalent) of 2000 in United Kingdom to that in United States?
Provide a short and direct response. 0.12. What is the ratio of the Emissions (1000 metric ton of CO2 equivalent) in 2005 in United Kingdom to that in United States?
Ensure brevity in your answer.  0.1. What is the ratio of the Emissions (1000 metric ton of CO2 equivalent) in 2008 in United Kingdom to that in United States?
Make the answer very short. 0.1. What is the ratio of the Emissions (1000 metric ton of CO2 equivalent) of 1990 in United Kingdom to that in Uruguay?
Offer a terse response. 3.89. What is the ratio of the Emissions (1000 metric ton of CO2 equivalent) of 2000 in United Kingdom to that in Uruguay?
Ensure brevity in your answer.  3.3. What is the ratio of the Emissions (1000 metric ton of CO2 equivalent) of 2005 in United Kingdom to that in Uruguay?
Give a very brief answer. 2.7. What is the ratio of the Emissions (1000 metric ton of CO2 equivalent) of 2008 in United Kingdom to that in Uruguay?
Your answer should be compact. 2.43. What is the ratio of the Emissions (1000 metric ton of CO2 equivalent) of 1990 in United States to that in Uruguay?
Offer a terse response. 26.09. What is the ratio of the Emissions (1000 metric ton of CO2 equivalent) of 2000 in United States to that in Uruguay?
Your answer should be compact. 27.67. What is the ratio of the Emissions (1000 metric ton of CO2 equivalent) of 2005 in United States to that in Uruguay?
Provide a succinct answer. 26.33. What is the ratio of the Emissions (1000 metric ton of CO2 equivalent) of 2008 in United States to that in Uruguay?
Your response must be concise. 24.49. What is the difference between the highest and the second highest Emissions (1000 metric ton of CO2 equivalent) in 1990?
Your answer should be compact. 1.20e+05. What is the difference between the highest and the second highest Emissions (1000 metric ton of CO2 equivalent) of 2000?
Keep it short and to the point. 1.49e+05. What is the difference between the highest and the second highest Emissions (1000 metric ton of CO2 equivalent) in 2005?
Keep it short and to the point. 1.61e+05. What is the difference between the highest and the second highest Emissions (1000 metric ton of CO2 equivalent) of 2008?
Give a very brief answer. 1.57e+05. What is the difference between the highest and the lowest Emissions (1000 metric ton of CO2 equivalent) of 1990?
Provide a succinct answer. 1.53e+05. What is the difference between the highest and the lowest Emissions (1000 metric ton of CO2 equivalent) of 2000?
Make the answer very short. 1.69e+05. What is the difference between the highest and the lowest Emissions (1000 metric ton of CO2 equivalent) of 2005?
Your response must be concise. 1.78e+05. What is the difference between the highest and the lowest Emissions (1000 metric ton of CO2 equivalent) of 2008?
Your answer should be compact. 1.74e+05. 